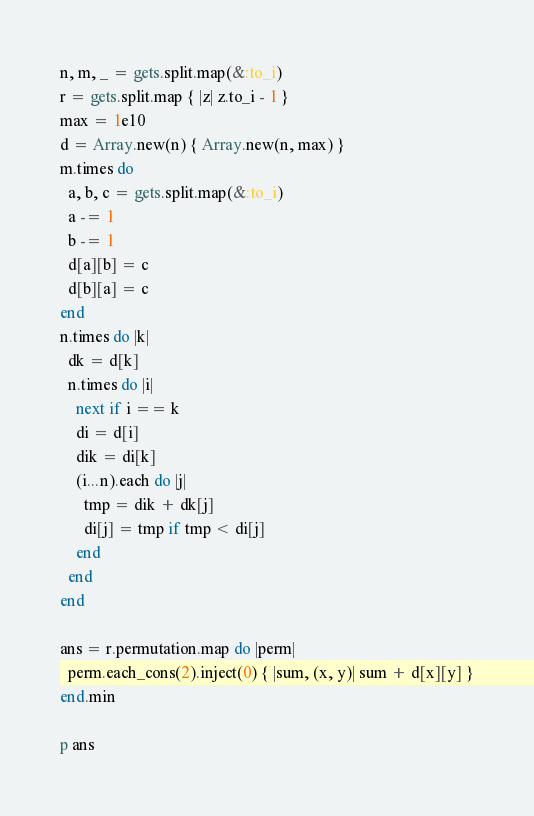Convert code to text. <code><loc_0><loc_0><loc_500><loc_500><_Ruby_>n, m, _ = gets.split.map(&:to_i)
r = gets.split.map { |z| z.to_i - 1 }
max = 1e10
d = Array.new(n) { Array.new(n, max) }
m.times do
  a, b, c = gets.split.map(&:to_i)
  a -= 1
  b -= 1
  d[a][b] = c
  d[b][a] = c
end
n.times do |k|
  dk = d[k]
  n.times do |i|
    next if i == k
    di = d[i]
    dik = di[k]
    (i...n).each do |j|
      tmp = dik + dk[j]
      di[j] = tmp if tmp < di[j]
    end
  end
end

ans = r.permutation.map do |perm|
  perm.each_cons(2).inject(0) { |sum, (x, y)| sum + d[x][y] }
end.min

p ans
</code> 